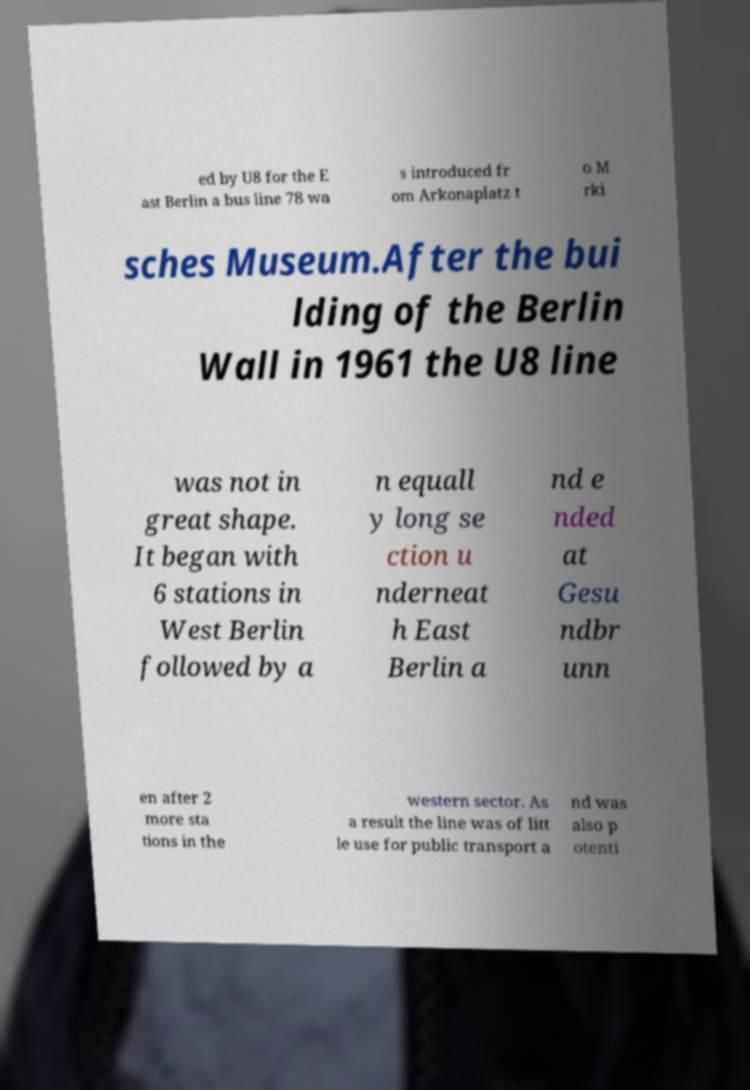Could you assist in decoding the text presented in this image and type it out clearly? ed by U8 for the E ast Berlin a bus line 78 wa s introduced fr om Arkonaplatz t o M rki sches Museum.After the bui lding of the Berlin Wall in 1961 the U8 line was not in great shape. It began with 6 stations in West Berlin followed by a n equall y long se ction u nderneat h East Berlin a nd e nded at Gesu ndbr unn en after 2 more sta tions in the western sector. As a result the line was of litt le use for public transport a nd was also p otenti 